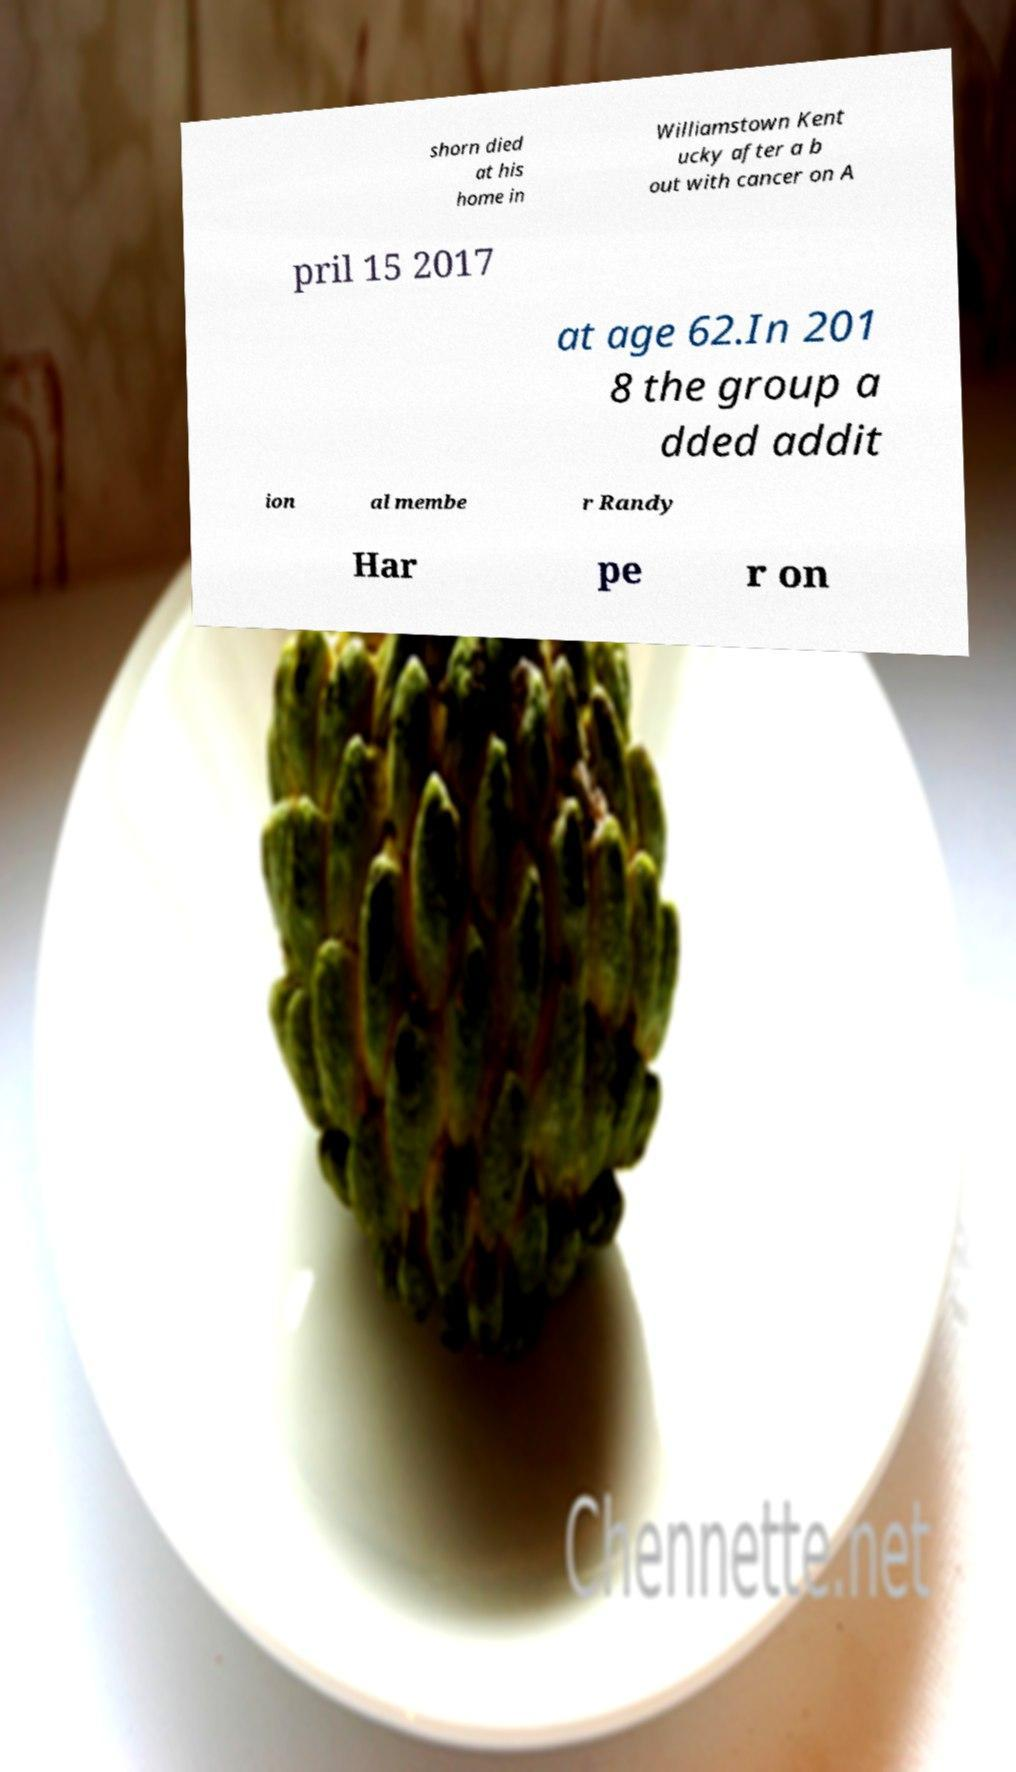Please identify and transcribe the text found in this image. shorn died at his home in Williamstown Kent ucky after a b out with cancer on A pril 15 2017 at age 62.In 201 8 the group a dded addit ion al membe r Randy Har pe r on 